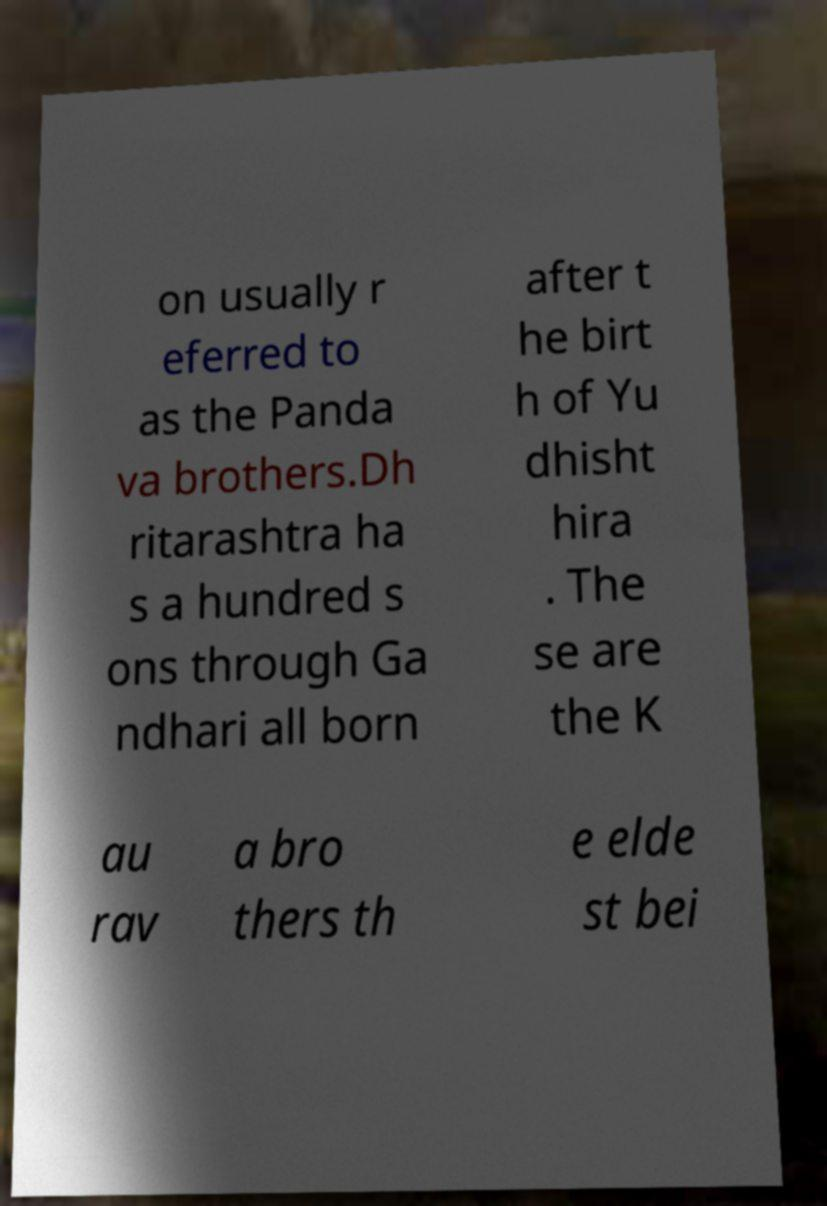There's text embedded in this image that I need extracted. Can you transcribe it verbatim? on usually r eferred to as the Panda va brothers.Dh ritarashtra ha s a hundred s ons through Ga ndhari all born after t he birt h of Yu dhisht hira . The se are the K au rav a bro thers th e elde st bei 